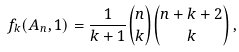Convert formula to latex. <formula><loc_0><loc_0><loc_500><loc_500>f _ { k } ( A _ { n } , 1 ) = \frac { 1 } { k + 1 } \binom { n } { k } \binom { n + k + 2 } { k } \, ,</formula> 